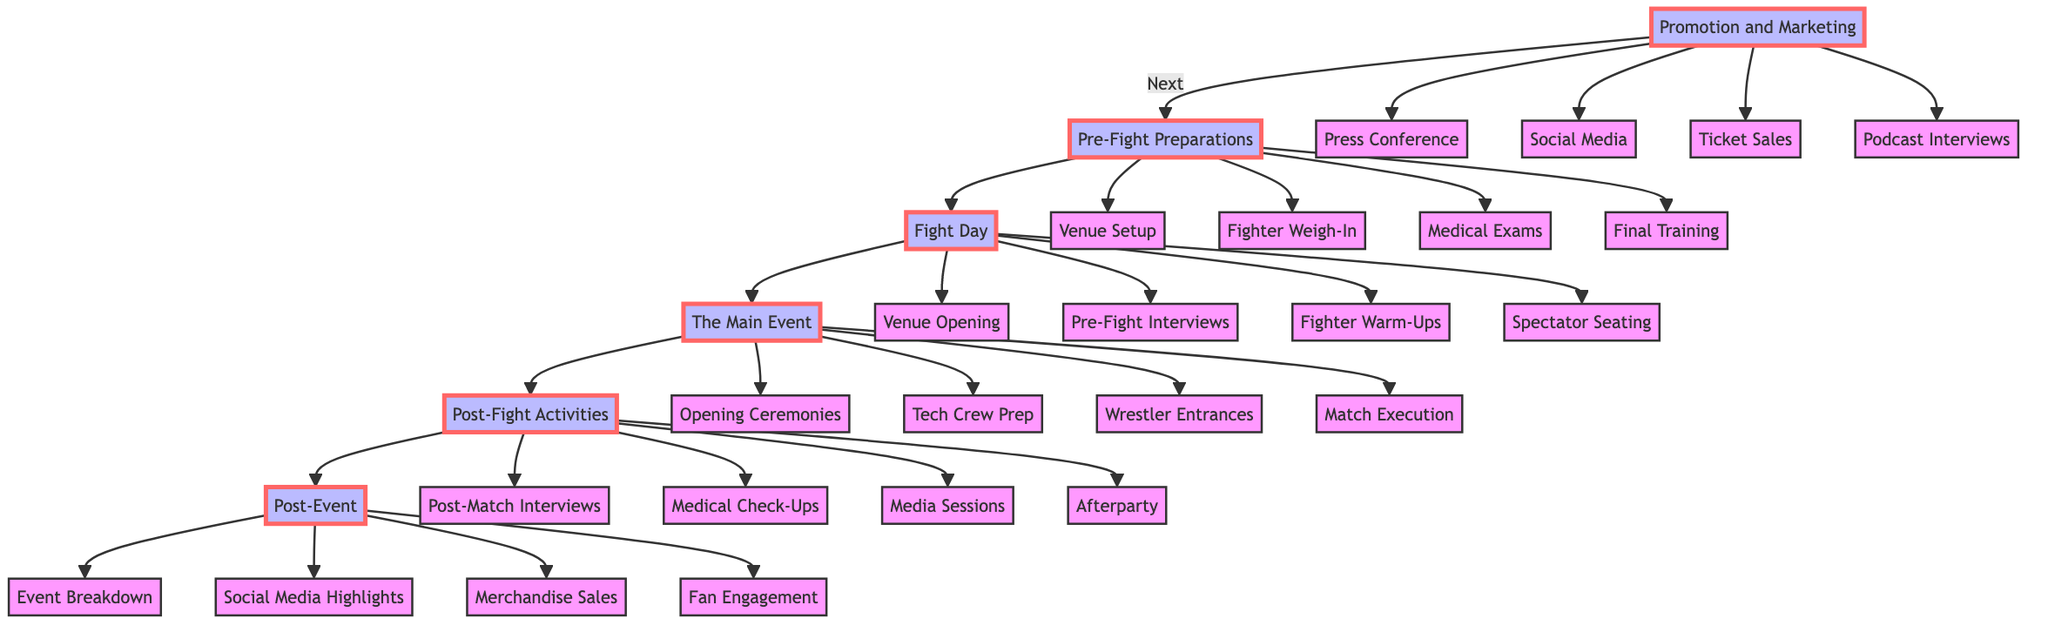What is the first stage in the timeline? The first stage in the timeline is listed as “Promotion and Marketing,” which is at the top of the diagram.
Answer: Promotion and Marketing How many activities are listed under the "Fight Day" stage? Under the "Fight Day" stage, there are four activities indicated: Venue Opening, Pre-Fight Interviews, Fighter Warm-Ups, and Spectator Seating. Counting these activities gives a total of four.
Answer: 4 What stage comes after "Post-Fight Activities"? Looking at the flow of the diagram, the stage that directly follows "Post-Fight Activities" is "Post-Event".
Answer: Post-Event Which two stages have "Medical Check-Ups" as part of their activities? "Medical Check-Ups" appears in the activities of "Pre-Fight Activities" and "Post-Fight Activities." These activities pertain to ensuring fighter readiness and post-match safety.
Answer: Pre-Fight Preparations, Post-Fight Activities What is the last activity listed in the "Post-Event" stage? Following the order in the timeline, the last activity listed under the "Post-Event" stage is "Fan Engagement Activities."
Answer: Fan Engagement Activities What activities are directly associated with the "The Main Event"? The activities associated with the "The Main Event" stage include: Opening Ceremonies, Technical Crew Preparations, Wrestler Entrances, and Match Execution. All four activities are directly linked to this stage.
Answer: Opening Ceremonies, Technical Crew Preparations, Wrestler Entrances, Match Execution How many stages are present in the timeline? There are a total of six stages present in the timeline as outlined in the diagram: Promotion and Marketing, Pre-Fight Preparations, Fight Day, The Main Event, Post-Fight Activities, and Post-Event. Count these stages for the total.
Answer: 6 What is the relationship between "Medical Examinations" and "Fighter Weigh-In"? "Medical Examinations" and "Fighter Weigh-In" are both activities listed under the same stage, which is "Pre-Fight Preparations." This relationship suggests that these activities occur simultaneously as part of the pre-fight process.
Answer: Same stage (Pre-Fight Preparations) 